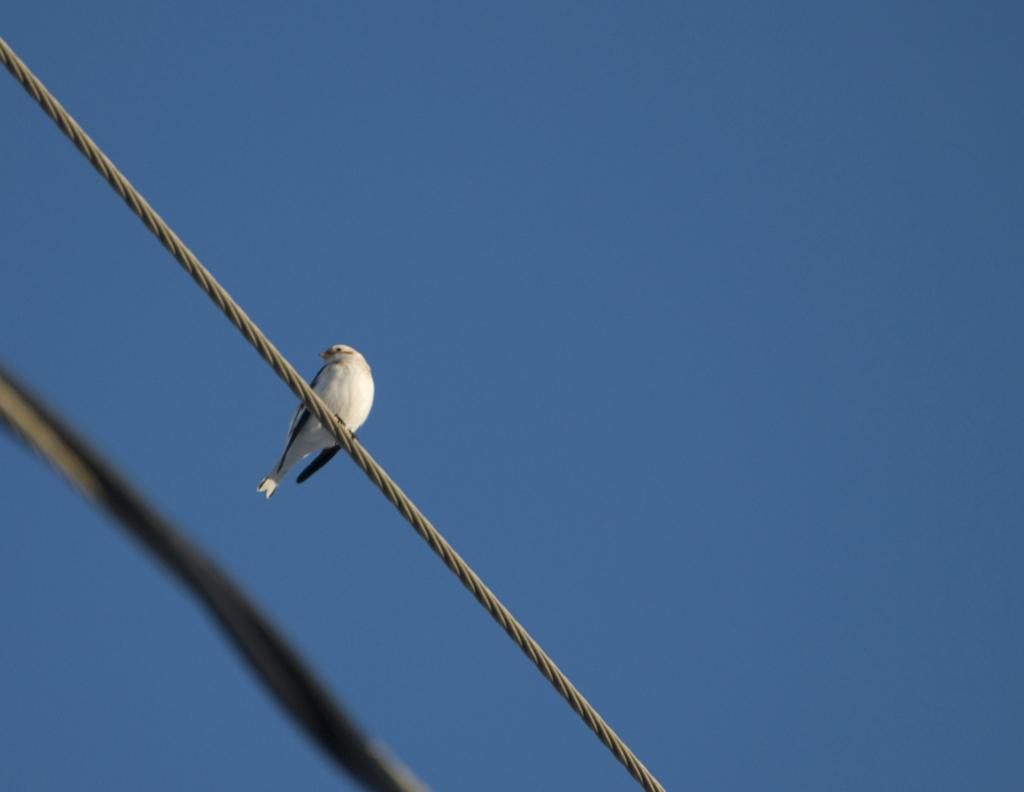Where was the picture taken? The picture was clicked outside. What can be seen on the cable in the image? There is a bird standing on a cable in the image. What is located in the left corner of the image? There is an object in the left corner of the image. What is visible in the background of the image? The sky is visible in the background of the image. What type of attention is the bird giving to the cap in the image? A: There is no cap present in the image, so the bird cannot be giving any attention to it. 